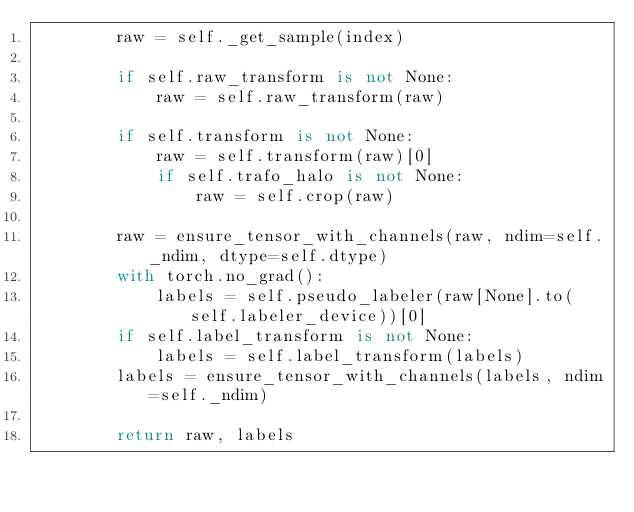Convert code to text. <code><loc_0><loc_0><loc_500><loc_500><_Python_>        raw = self._get_sample(index)

        if self.raw_transform is not None:
            raw = self.raw_transform(raw)

        if self.transform is not None:
            raw = self.transform(raw)[0]
            if self.trafo_halo is not None:
                raw = self.crop(raw)

        raw = ensure_tensor_with_channels(raw, ndim=self._ndim, dtype=self.dtype)
        with torch.no_grad():
            labels = self.pseudo_labeler(raw[None].to(self.labeler_device))[0]
        if self.label_transform is not None:
            labels = self.label_transform(labels)
        labels = ensure_tensor_with_channels(labels, ndim=self._ndim)

        return raw, labels
</code> 